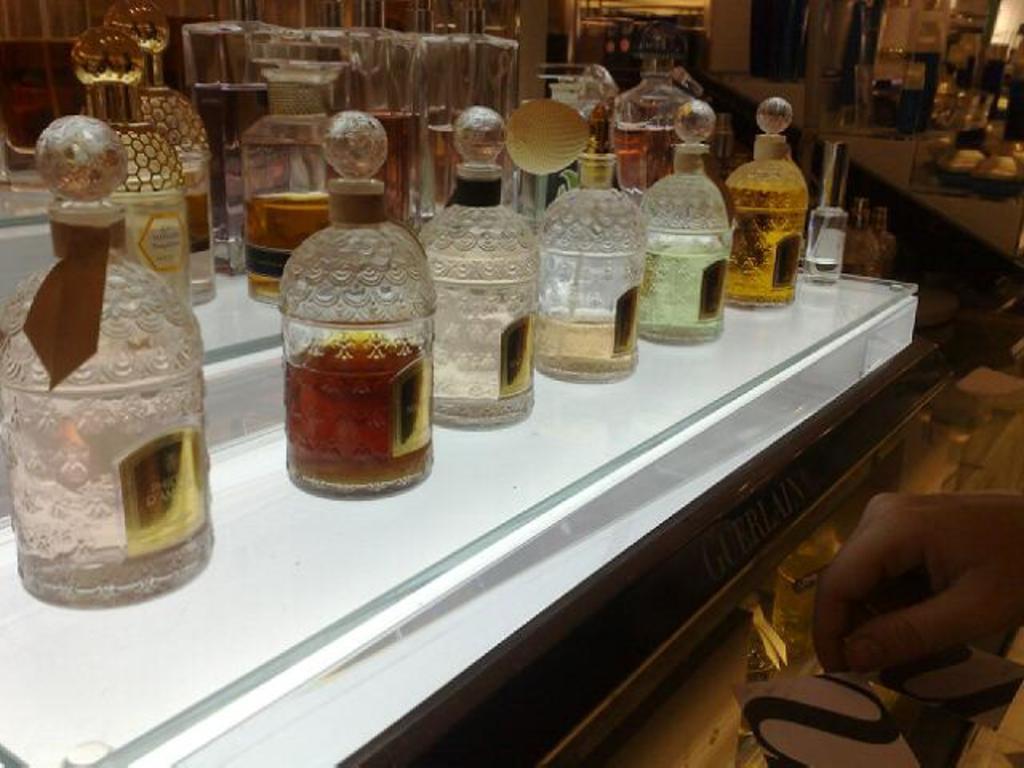How would you summarize this image in a sentence or two? There are group of bottles kept on the table in this image. At the right side hand of the person is visible. 